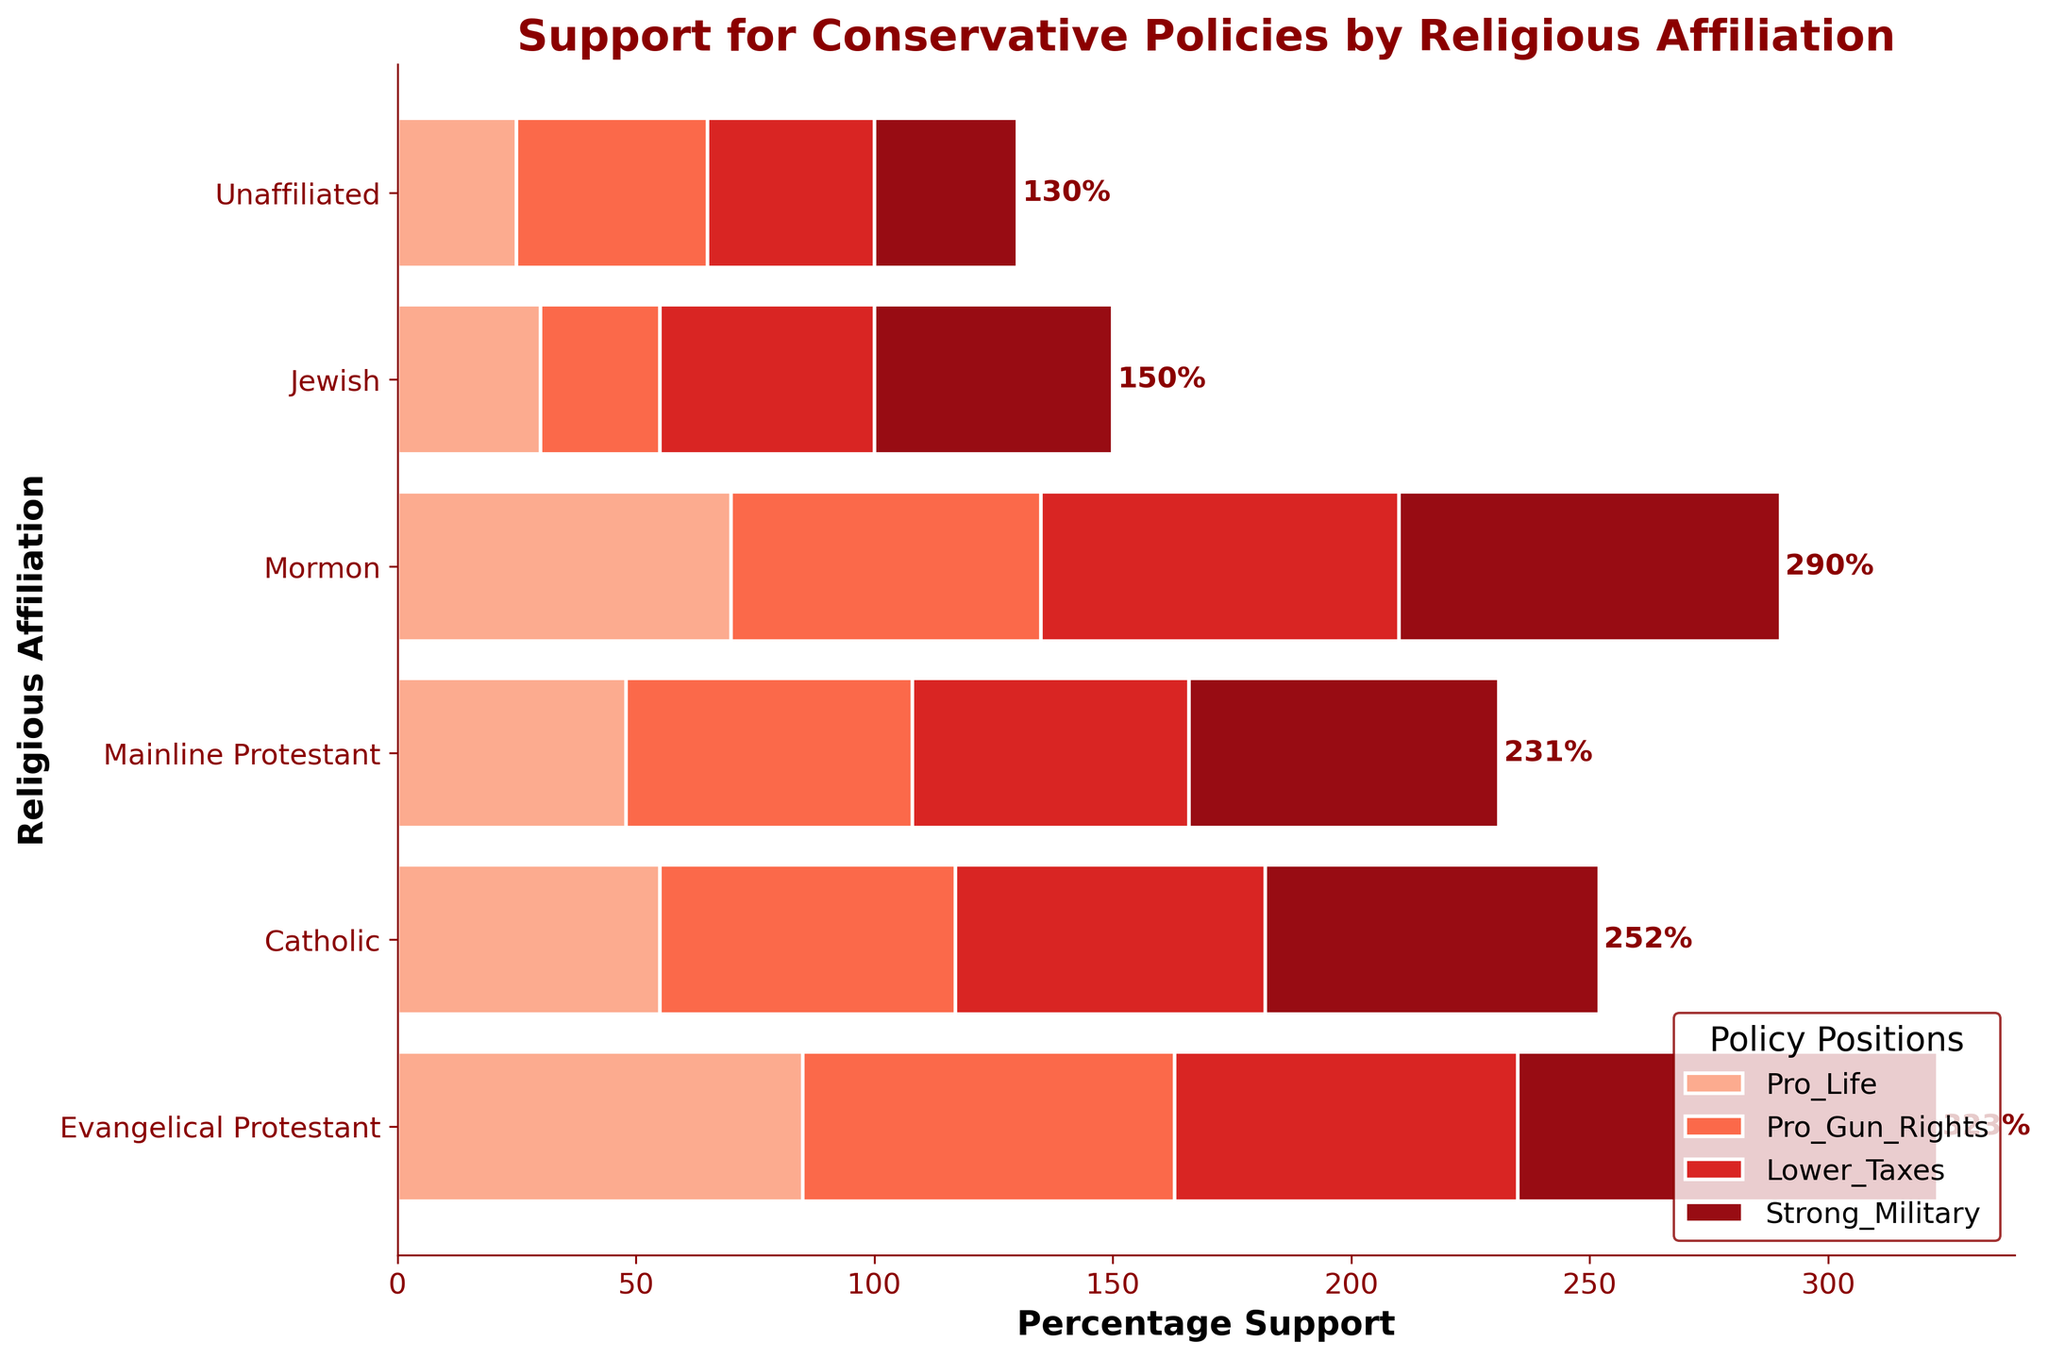What are the four policy positions shown in the plot? The plot includes four policy positions, each labeled with a different color. They are listed in the legend at the bottom right of the plot.
Answer: Pro Life, Pro Gun Rights, Lower Taxes, Strong Military Which religious affiliation has the highest overall support for conservative policies? To find the religious affiliation with the highest overall support, we can look at the total length of the horizontal bars. Evangelical Protestant has the longest bar, indicating the highest overall support.
Answer: Evangelical Protestant How much support do Mainline Protestants have for Pro Gun Rights? The plot shows individual bars for each policy position within each religious affiliation. The segment corresponding to Pro Gun Rights for Mainline Protestant is labeled, and its length indicates the support percentage.
Answer: 60% Which policy position shows the highest support among Mormons? By looking at the segments within the Mormon bar, the tallest one indicates the highest support, which is marked with its policy position.
Answer: Strong Military What is the combined support for Pro Life and Lower Taxes among Catholics? To find the combined support, add the individual support percentages for Pro Life and Lower Taxes among Catholics, which can be read directly from the plot.
Answer: 55% + 65% = 120% Compare the support for Strong Military between Evangelical Protestant and Jewish affiliations. The segments corresponding to Strong Military within Evangelical Protestant and Jewish affiliations can be compared by their length percentage and position. Evangelical Protestant shows 88%, while Jewish shows 50%.
Answer: Evangelical Protestant has 38% more support Which religious affiliation has the lowest support for Pro Life? The shortest bar segment corresponding to Pro Life indicates the lowest support, which can be directly observed from the plot.
Answer: Unaffiliated How does the support for Pro Gun Rights among Catholics compare with that among Mormons? By comparing the length of the Pro Gun Rights segments for Catholics and Mormons, Catholics have 62% support whereas Mormons have 65%.
Answer: Mormons have 3% more support Calculate the average support for Lower Taxes among all religious affiliations. To find the average, sum the support percentages for Lower Taxes across all affiliations and divide by the number of affiliations. (72 + 65 + 58 + 75 + 45 + 35) / 6 = 350 / 6
Answer: Approximately 58.3% Which policy position has the most consistent support across all religious affiliations? The most consistent support would be indicated by the smallest range between the highest and lowest support values. By comparing the range of support percentages for each policy, Pro Gun Rights varies the least from 25% to 78%.
Answer: Pro Gun Rights 